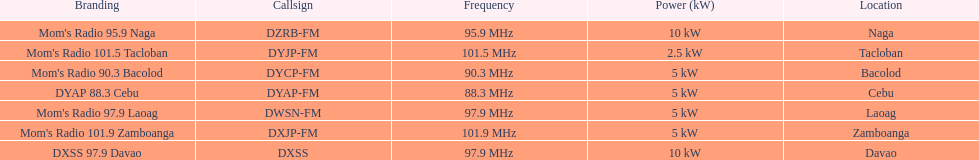How many stations have at least 5 kw or more listed in the power column? 6. Would you be able to parse every entry in this table? {'header': ['Branding', 'Callsign', 'Frequency', 'Power (kW)', 'Location'], 'rows': [["Mom's Radio 95.9 Naga", 'DZRB-FM', '95.9\xa0MHz', '10\xa0kW', 'Naga'], ["Mom's Radio 101.5 Tacloban", 'DYJP-FM', '101.5\xa0MHz', '2.5\xa0kW', 'Tacloban'], ["Mom's Radio 90.3 Bacolod", 'DYCP-FM', '90.3\xa0MHz', '5\xa0kW', 'Bacolod'], ['DYAP 88.3 Cebu', 'DYAP-FM', '88.3\xa0MHz', '5\xa0kW', 'Cebu'], ["Mom's Radio 97.9 Laoag", 'DWSN-FM', '97.9\xa0MHz', '5\xa0kW', 'Laoag'], ["Mom's Radio 101.9 Zamboanga", 'DXJP-FM', '101.9\xa0MHz', '5\xa0kW', 'Zamboanga'], ['DXSS 97.9 Davao', 'DXSS', '97.9\xa0MHz', '10\xa0kW', 'Davao']]} 